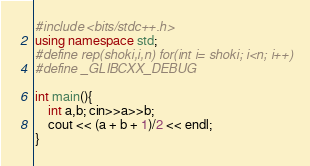Convert code to text. <code><loc_0><loc_0><loc_500><loc_500><_C++_>#include <bits/stdc++.h>
using namespace std;
#define rep(shoki,i,n) for(int i= shoki; i<n; i++)
#define _GLIBCXX_DEBUG

int main(){
    int a,b; cin>>a>>b;
    cout << (a + b + 1)/2 << endl;
}
</code> 